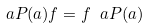<formula> <loc_0><loc_0><loc_500><loc_500>\ a P ( a ) f = f \ a P ( a )</formula> 